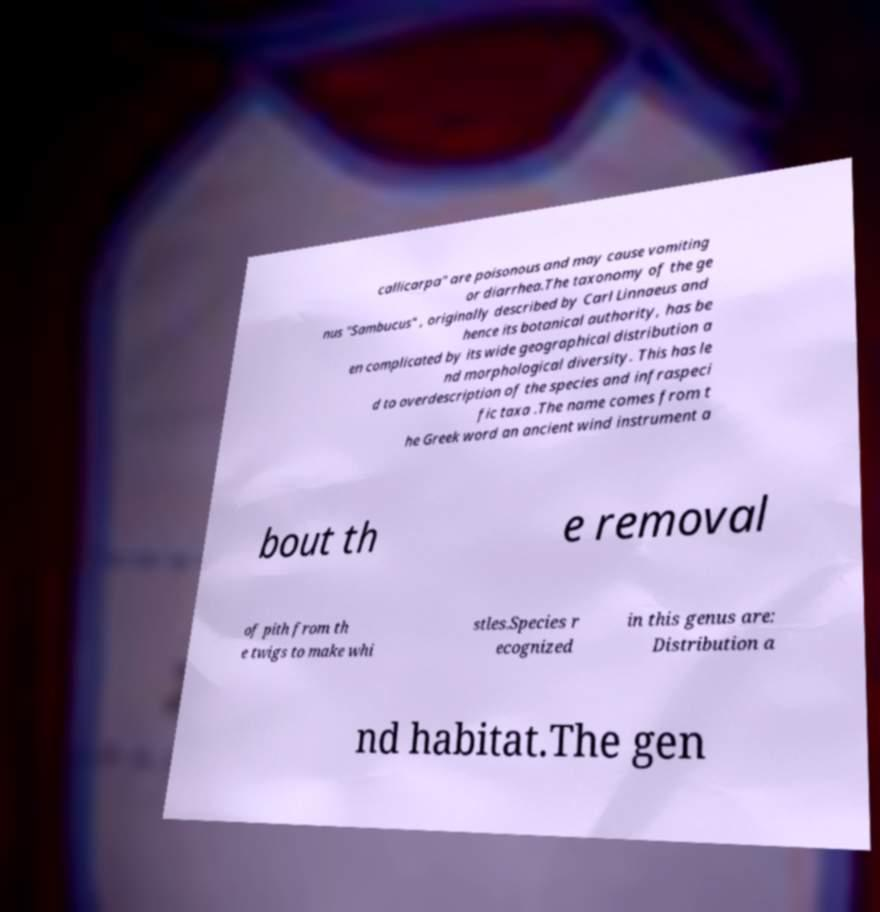What messages or text are displayed in this image? I need them in a readable, typed format. callicarpa" are poisonous and may cause vomiting or diarrhea.The taxonomy of the ge nus "Sambucus" , originally described by Carl Linnaeus and hence its botanical authority, has be en complicated by its wide geographical distribution a nd morphological diversity. This has le d to overdescription of the species and infraspeci fic taxa .The name comes from t he Greek word an ancient wind instrument a bout th e removal of pith from th e twigs to make whi stles.Species r ecognized in this genus are: Distribution a nd habitat.The gen 